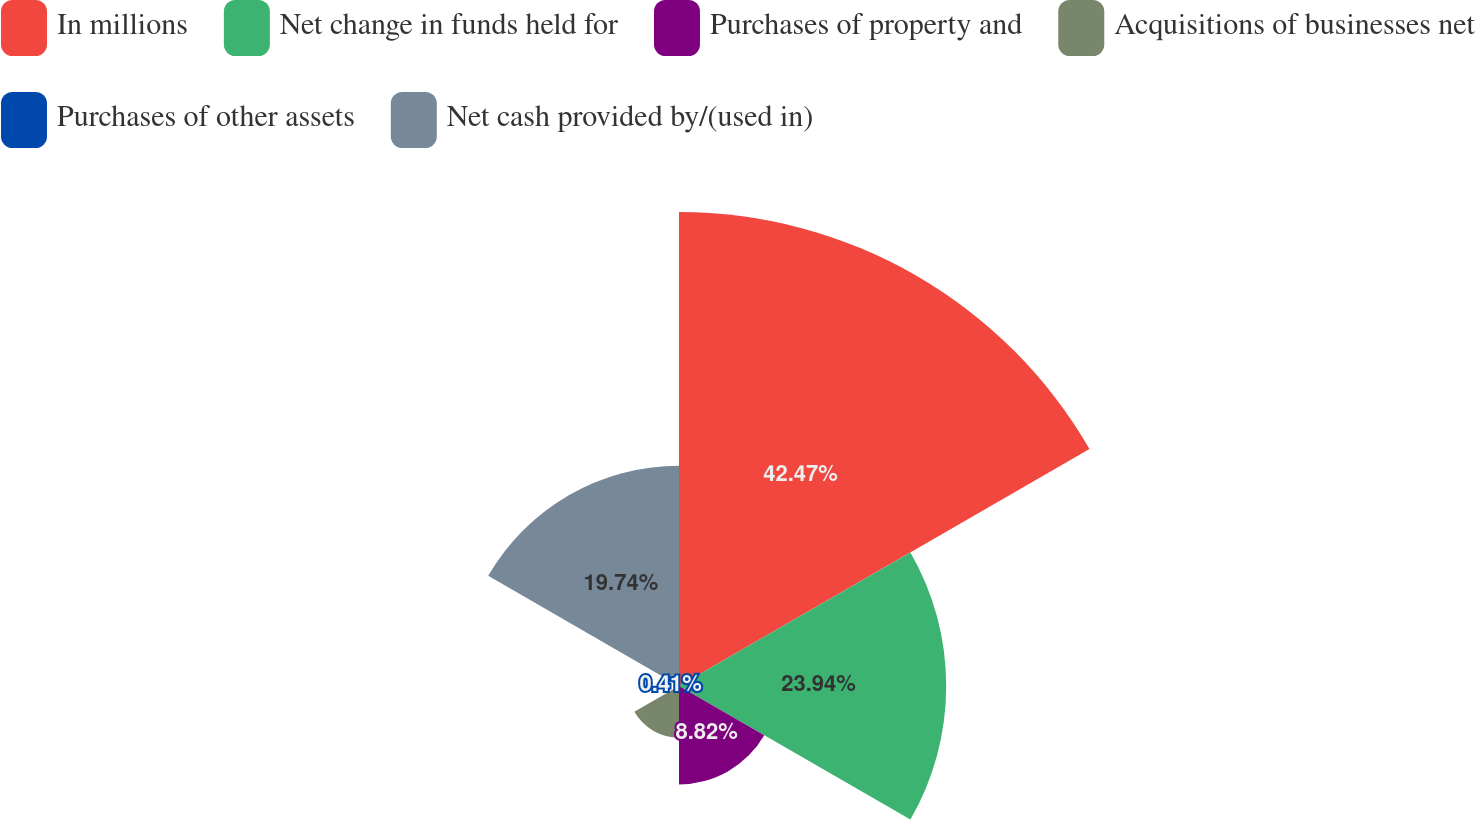Convert chart. <chart><loc_0><loc_0><loc_500><loc_500><pie_chart><fcel>In millions<fcel>Net change in funds held for<fcel>Purchases of property and<fcel>Acquisitions of businesses net<fcel>Purchases of other assets<fcel>Net cash provided by/(used in)<nl><fcel>42.47%<fcel>23.94%<fcel>8.82%<fcel>4.62%<fcel>0.41%<fcel>19.74%<nl></chart> 